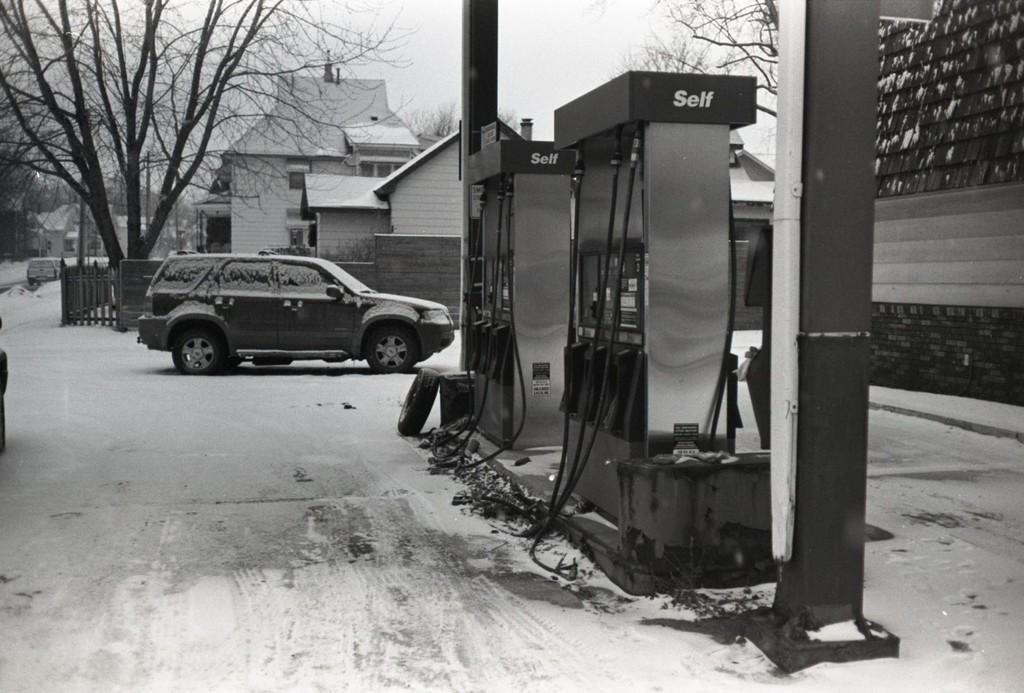In one or two sentences, can you explain what this image depicts? This picture is clicked outside the city. Here, we see the car moving on the road. Beside that, we see a petrol pump. Behind that, we see a building. There are many trees and buildings in the background and the road is covered with ice. This is a black and white picture. 